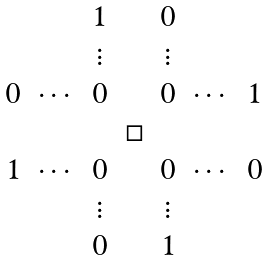<formula> <loc_0><loc_0><loc_500><loc_500>\begin{array} { c c c c c c c } & & 1 & & 0 & & \\ & & \vdots & & \vdots & & \\ 0 & \cdots & 0 & & 0 & \cdots & 1 \\ & & & \Box & & & \\ 1 & \cdots & 0 & & 0 & \cdots & 0 \\ & & \vdots & & \vdots & & \\ & & 0 & & 1 & & \end{array}</formula> 